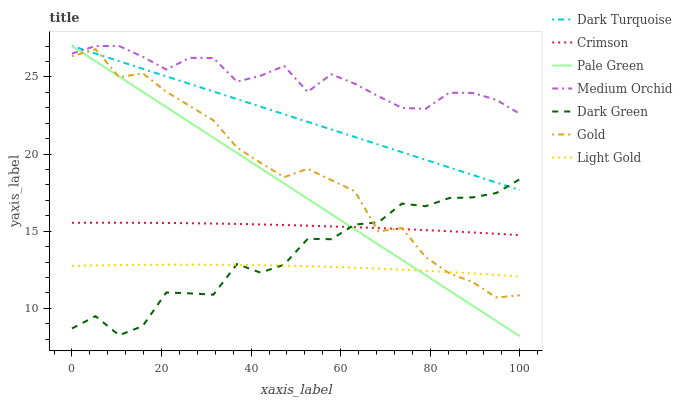Does Light Gold have the minimum area under the curve?
Answer yes or no. Yes. Does Medium Orchid have the maximum area under the curve?
Answer yes or no. Yes. Does Dark Turquoise have the minimum area under the curve?
Answer yes or no. No. Does Dark Turquoise have the maximum area under the curve?
Answer yes or no. No. Is Dark Turquoise the smoothest?
Answer yes or no. Yes. Is Dark Green the roughest?
Answer yes or no. Yes. Is Medium Orchid the smoothest?
Answer yes or no. No. Is Medium Orchid the roughest?
Answer yes or no. No. Does Dark Turquoise have the lowest value?
Answer yes or no. No. Does Pale Green have the highest value?
Answer yes or no. Yes. Does Crimson have the highest value?
Answer yes or no. No. Is Light Gold less than Medium Orchid?
Answer yes or no. Yes. Is Crimson greater than Light Gold?
Answer yes or no. Yes. Does Crimson intersect Pale Green?
Answer yes or no. Yes. Is Crimson less than Pale Green?
Answer yes or no. No. Is Crimson greater than Pale Green?
Answer yes or no. No. Does Light Gold intersect Medium Orchid?
Answer yes or no. No. 